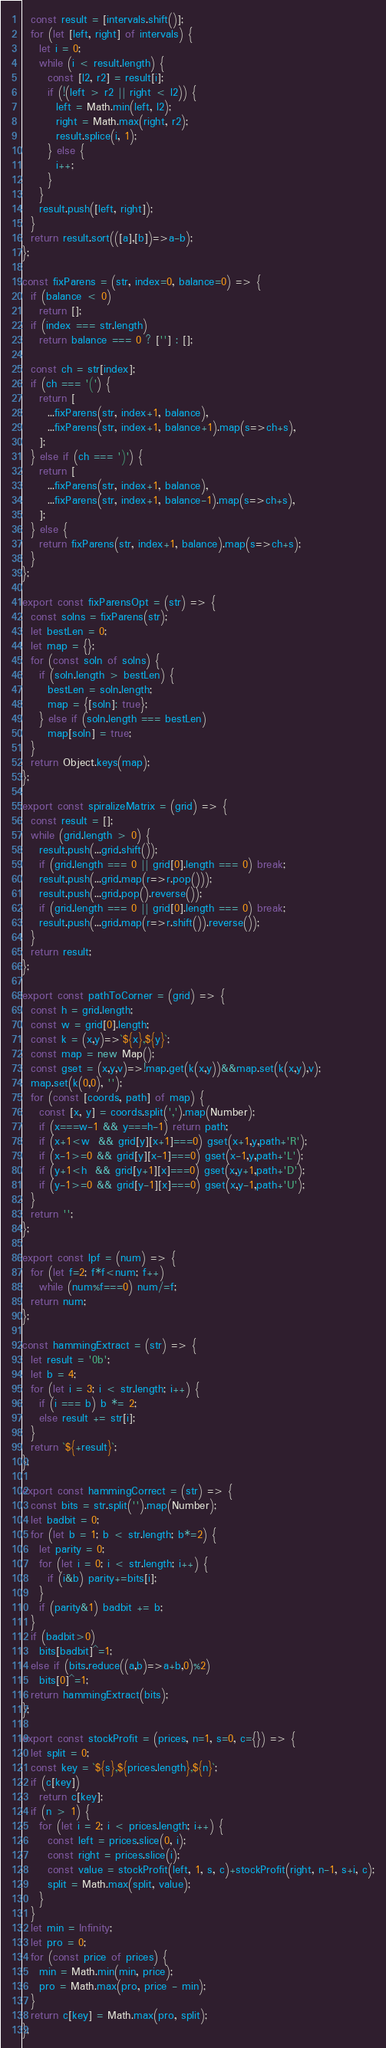<code> <loc_0><loc_0><loc_500><loc_500><_JavaScript_>  const result = [intervals.shift()];
  for (let [left, right] of intervals) {
    let i = 0;
    while (i < result.length) {
      const [l2, r2] = result[i];
      if (!(left > r2 || right < l2)) {
        left = Math.min(left, l2);
        right = Math.max(right, r2);
        result.splice(i, 1);
      } else {
        i++;
      }
    }
    result.push([left, right]);
  }
  return result.sort(([a],[b])=>a-b);
};

const fixParens = (str, index=0, balance=0) => {
  if (balance < 0)
    return [];
  if (index === str.length)
    return balance === 0 ? [''] : [];

  const ch = str[index];
  if (ch === '(') {
    return [
      ...fixParens(str, index+1, balance),
      ...fixParens(str, index+1, balance+1).map(s=>ch+s),
    ];
  } else if (ch === ')') {
    return [
      ...fixParens(str, index+1, balance),
      ...fixParens(str, index+1, balance-1).map(s=>ch+s),
    ];
  } else {
    return fixParens(str, index+1, balance).map(s=>ch+s);
  }
};

export const fixParensOpt = (str) => {
  const solns = fixParens(str);
  let bestLen = 0;
  let map = {};
  for (const soln of solns) {
    if (soln.length > bestLen) {
      bestLen = soln.length;
      map = {[soln]: true};
    } else if (soln.length === bestLen)
      map[soln] = true;
  }
  return Object.keys(map);
};

export const spiralizeMatrix = (grid) => {
  const result = [];
  while (grid.length > 0) {
    result.push(...grid.shift());
    if (grid.length === 0 || grid[0].length === 0) break;
    result.push(...grid.map(r=>r.pop()));
    result.push(...grid.pop().reverse());
    if (grid.length === 0 || grid[0].length === 0) break;
    result.push(...grid.map(r=>r.shift()).reverse());
  }
  return result;
};

export const pathToCorner = (grid) => {
  const h = grid.length;
  const w = grid[0].length;
  const k = (x,y)=>`${x},${y}`;
  const map = new Map();
  const gset = (x,y,v)=>!map.get(k(x,y))&&map.set(k(x,y),v);
  map.set(k(0,0), '');
  for (const [coords, path] of map) {
    const [x, y] = coords.split(',').map(Number);
    if (x===w-1 && y===h-1) return path;
    if (x+1<w  && grid[y][x+1]===0) gset(x+1,y,path+'R');
    if (x-1>=0 && grid[y][x-1]===0) gset(x-1,y,path+'L');
    if (y+1<h  && grid[y+1][x]===0) gset(x,y+1,path+'D');
    if (y-1>=0 && grid[y-1][x]===0) gset(x,y-1,path+'U');
  }
  return '';
};

export const lpf = (num) => {
  for (let f=2; f*f<num; f++)
    while (num%f===0) num/=f;
  return num;
};

const hammingExtract = (str) => {
  let result = '0b';
  let b = 4;
  for (let i = 3; i < str.length; i++) {
    if (i === b) b *= 2;
    else result += str[i];
  }
  return `${+result}`;
};

export const hammingCorrect = (str) => {
  const bits = str.split('').map(Number);
  let badbit = 0;
  for (let b = 1; b < str.length; b*=2) {
    let parity = 0;
    for (let i = 0; i < str.length; i++) {
      if (i&b) parity+=bits[i];
    }
    if (parity&1) badbit += b;
  }
  if (badbit>0)
    bits[badbit]^=1;
  else if (bits.reduce((a,b)=>a+b,0)%2)
    bits[0]^=1;
  return hammingExtract(bits);
};

export const stockProfit = (prices, n=1, s=0, c={}) => {
  let split = 0;
  const key = `${s},${prices.length},${n}`;
  if (c[key])
    return c[key];
  if (n > 1) {
    for (let i = 2; i < prices.length; i++) {
      const left = prices.slice(0, i);
      const right = prices.slice(i);
      const value = stockProfit(left, 1, s, c)+stockProfit(right, n-1, s+i, c);
      split = Math.max(split, value);
    }
  }
  let min = Infinity;
  let pro = 0;
  for (const price of prices) {
    min = Math.min(min, price);
    pro = Math.max(pro, price - min);
  }
  return c[key] = Math.max(pro, split);
};</code> 